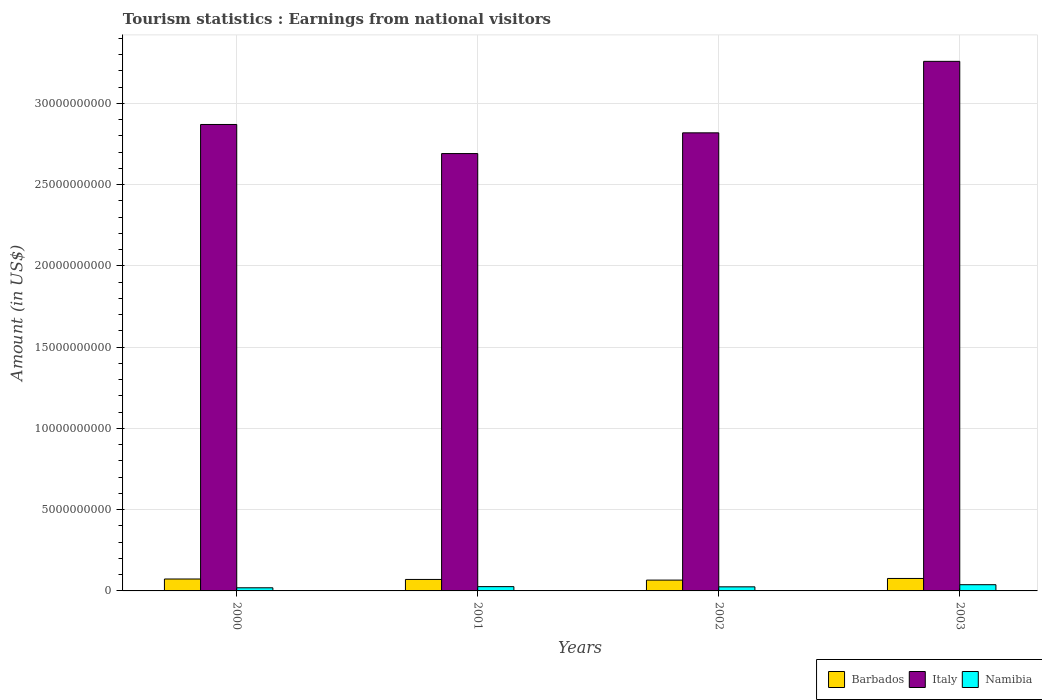How many different coloured bars are there?
Your response must be concise. 3. How many groups of bars are there?
Your answer should be very brief. 4. Are the number of bars per tick equal to the number of legend labels?
Keep it short and to the point. Yes. How many bars are there on the 1st tick from the left?
Provide a succinct answer. 3. How many bars are there on the 1st tick from the right?
Ensure brevity in your answer.  3. What is the earnings from national visitors in Italy in 2003?
Ensure brevity in your answer.  3.26e+1. Across all years, what is the maximum earnings from national visitors in Barbados?
Give a very brief answer. 7.67e+08. Across all years, what is the minimum earnings from national visitors in Namibia?
Provide a succinct answer. 1.93e+08. What is the total earnings from national visitors in Italy in the graph?
Ensure brevity in your answer.  1.16e+11. What is the difference between the earnings from national visitors in Italy in 2001 and that in 2003?
Ensure brevity in your answer.  -5.68e+09. What is the difference between the earnings from national visitors in Namibia in 2000 and the earnings from national visitors in Barbados in 2002?
Provide a short and direct response. -4.73e+08. What is the average earnings from national visitors in Namibia per year?
Your response must be concise. 2.73e+08. In the year 2003, what is the difference between the earnings from national visitors in Barbados and earnings from national visitors in Italy?
Provide a succinct answer. -3.18e+1. What is the ratio of the earnings from national visitors in Barbados in 2000 to that in 2003?
Provide a succinct answer. 0.96. What is the difference between the highest and the second highest earnings from national visitors in Italy?
Provide a succinct answer. 3.88e+09. What is the difference between the highest and the lowest earnings from national visitors in Barbados?
Your answer should be very brief. 1.01e+08. In how many years, is the earnings from national visitors in Italy greater than the average earnings from national visitors in Italy taken over all years?
Your response must be concise. 1. Is the sum of the earnings from national visitors in Barbados in 2001 and 2003 greater than the maximum earnings from national visitors in Italy across all years?
Keep it short and to the point. No. What does the 3rd bar from the right in 2001 represents?
Your response must be concise. Barbados. Are all the bars in the graph horizontal?
Make the answer very short. No. How many years are there in the graph?
Your answer should be compact. 4. Does the graph contain any zero values?
Make the answer very short. No. Does the graph contain grids?
Offer a very short reply. Yes. How many legend labels are there?
Provide a short and direct response. 3. How are the legend labels stacked?
Make the answer very short. Horizontal. What is the title of the graph?
Your answer should be very brief. Tourism statistics : Earnings from national visitors. What is the label or title of the Y-axis?
Keep it short and to the point. Amount (in US$). What is the Amount (in US$) of Barbados in 2000?
Make the answer very short. 7.33e+08. What is the Amount (in US$) in Italy in 2000?
Provide a short and direct response. 2.87e+1. What is the Amount (in US$) of Namibia in 2000?
Your response must be concise. 1.93e+08. What is the Amount (in US$) of Barbados in 2001?
Provide a short and direct response. 7.06e+08. What is the Amount (in US$) of Italy in 2001?
Offer a very short reply. 2.69e+1. What is the Amount (in US$) of Namibia in 2001?
Give a very brief answer. 2.64e+08. What is the Amount (in US$) of Barbados in 2002?
Make the answer very short. 6.66e+08. What is the Amount (in US$) of Italy in 2002?
Make the answer very short. 2.82e+1. What is the Amount (in US$) of Namibia in 2002?
Offer a very short reply. 2.51e+08. What is the Amount (in US$) of Barbados in 2003?
Your answer should be very brief. 7.67e+08. What is the Amount (in US$) in Italy in 2003?
Provide a succinct answer. 3.26e+1. What is the Amount (in US$) of Namibia in 2003?
Make the answer very short. 3.83e+08. Across all years, what is the maximum Amount (in US$) in Barbados?
Give a very brief answer. 7.67e+08. Across all years, what is the maximum Amount (in US$) of Italy?
Keep it short and to the point. 3.26e+1. Across all years, what is the maximum Amount (in US$) of Namibia?
Offer a very short reply. 3.83e+08. Across all years, what is the minimum Amount (in US$) in Barbados?
Your response must be concise. 6.66e+08. Across all years, what is the minimum Amount (in US$) of Italy?
Provide a succinct answer. 2.69e+1. Across all years, what is the minimum Amount (in US$) in Namibia?
Give a very brief answer. 1.93e+08. What is the total Amount (in US$) of Barbados in the graph?
Offer a very short reply. 2.87e+09. What is the total Amount (in US$) of Italy in the graph?
Offer a terse response. 1.16e+11. What is the total Amount (in US$) of Namibia in the graph?
Your answer should be compact. 1.09e+09. What is the difference between the Amount (in US$) in Barbados in 2000 and that in 2001?
Your answer should be very brief. 2.70e+07. What is the difference between the Amount (in US$) in Italy in 2000 and that in 2001?
Provide a short and direct response. 1.79e+09. What is the difference between the Amount (in US$) of Namibia in 2000 and that in 2001?
Make the answer very short. -7.10e+07. What is the difference between the Amount (in US$) of Barbados in 2000 and that in 2002?
Offer a terse response. 6.70e+07. What is the difference between the Amount (in US$) in Italy in 2000 and that in 2002?
Make the answer very short. 5.14e+08. What is the difference between the Amount (in US$) of Namibia in 2000 and that in 2002?
Give a very brief answer. -5.80e+07. What is the difference between the Amount (in US$) of Barbados in 2000 and that in 2003?
Your answer should be compact. -3.40e+07. What is the difference between the Amount (in US$) in Italy in 2000 and that in 2003?
Your answer should be compact. -3.88e+09. What is the difference between the Amount (in US$) in Namibia in 2000 and that in 2003?
Give a very brief answer. -1.90e+08. What is the difference between the Amount (in US$) of Barbados in 2001 and that in 2002?
Provide a succinct answer. 4.00e+07. What is the difference between the Amount (in US$) in Italy in 2001 and that in 2002?
Ensure brevity in your answer.  -1.28e+09. What is the difference between the Amount (in US$) of Namibia in 2001 and that in 2002?
Make the answer very short. 1.30e+07. What is the difference between the Amount (in US$) of Barbados in 2001 and that in 2003?
Provide a succinct answer. -6.10e+07. What is the difference between the Amount (in US$) in Italy in 2001 and that in 2003?
Your answer should be very brief. -5.68e+09. What is the difference between the Amount (in US$) of Namibia in 2001 and that in 2003?
Give a very brief answer. -1.19e+08. What is the difference between the Amount (in US$) of Barbados in 2002 and that in 2003?
Ensure brevity in your answer.  -1.01e+08. What is the difference between the Amount (in US$) in Italy in 2002 and that in 2003?
Ensure brevity in your answer.  -4.40e+09. What is the difference between the Amount (in US$) in Namibia in 2002 and that in 2003?
Make the answer very short. -1.32e+08. What is the difference between the Amount (in US$) of Barbados in 2000 and the Amount (in US$) of Italy in 2001?
Provide a short and direct response. -2.62e+1. What is the difference between the Amount (in US$) of Barbados in 2000 and the Amount (in US$) of Namibia in 2001?
Provide a short and direct response. 4.69e+08. What is the difference between the Amount (in US$) of Italy in 2000 and the Amount (in US$) of Namibia in 2001?
Give a very brief answer. 2.84e+1. What is the difference between the Amount (in US$) in Barbados in 2000 and the Amount (in US$) in Italy in 2002?
Provide a short and direct response. -2.75e+1. What is the difference between the Amount (in US$) of Barbados in 2000 and the Amount (in US$) of Namibia in 2002?
Your answer should be compact. 4.82e+08. What is the difference between the Amount (in US$) in Italy in 2000 and the Amount (in US$) in Namibia in 2002?
Keep it short and to the point. 2.85e+1. What is the difference between the Amount (in US$) in Barbados in 2000 and the Amount (in US$) in Italy in 2003?
Keep it short and to the point. -3.19e+1. What is the difference between the Amount (in US$) in Barbados in 2000 and the Amount (in US$) in Namibia in 2003?
Offer a terse response. 3.50e+08. What is the difference between the Amount (in US$) of Italy in 2000 and the Amount (in US$) of Namibia in 2003?
Offer a very short reply. 2.83e+1. What is the difference between the Amount (in US$) in Barbados in 2001 and the Amount (in US$) in Italy in 2002?
Provide a short and direct response. -2.75e+1. What is the difference between the Amount (in US$) in Barbados in 2001 and the Amount (in US$) in Namibia in 2002?
Your response must be concise. 4.55e+08. What is the difference between the Amount (in US$) of Italy in 2001 and the Amount (in US$) of Namibia in 2002?
Offer a very short reply. 2.67e+1. What is the difference between the Amount (in US$) in Barbados in 2001 and the Amount (in US$) in Italy in 2003?
Offer a very short reply. -3.19e+1. What is the difference between the Amount (in US$) of Barbados in 2001 and the Amount (in US$) of Namibia in 2003?
Give a very brief answer. 3.23e+08. What is the difference between the Amount (in US$) in Italy in 2001 and the Amount (in US$) in Namibia in 2003?
Provide a succinct answer. 2.65e+1. What is the difference between the Amount (in US$) of Barbados in 2002 and the Amount (in US$) of Italy in 2003?
Offer a very short reply. -3.19e+1. What is the difference between the Amount (in US$) in Barbados in 2002 and the Amount (in US$) in Namibia in 2003?
Give a very brief answer. 2.83e+08. What is the difference between the Amount (in US$) of Italy in 2002 and the Amount (in US$) of Namibia in 2003?
Offer a very short reply. 2.78e+1. What is the average Amount (in US$) in Barbados per year?
Keep it short and to the point. 7.18e+08. What is the average Amount (in US$) in Italy per year?
Your response must be concise. 2.91e+1. What is the average Amount (in US$) of Namibia per year?
Offer a terse response. 2.73e+08. In the year 2000, what is the difference between the Amount (in US$) in Barbados and Amount (in US$) in Italy?
Make the answer very short. -2.80e+1. In the year 2000, what is the difference between the Amount (in US$) in Barbados and Amount (in US$) in Namibia?
Provide a succinct answer. 5.40e+08. In the year 2000, what is the difference between the Amount (in US$) of Italy and Amount (in US$) of Namibia?
Keep it short and to the point. 2.85e+1. In the year 2001, what is the difference between the Amount (in US$) in Barbados and Amount (in US$) in Italy?
Your response must be concise. -2.62e+1. In the year 2001, what is the difference between the Amount (in US$) in Barbados and Amount (in US$) in Namibia?
Give a very brief answer. 4.42e+08. In the year 2001, what is the difference between the Amount (in US$) in Italy and Amount (in US$) in Namibia?
Make the answer very short. 2.67e+1. In the year 2002, what is the difference between the Amount (in US$) in Barbados and Amount (in US$) in Italy?
Ensure brevity in your answer.  -2.75e+1. In the year 2002, what is the difference between the Amount (in US$) in Barbados and Amount (in US$) in Namibia?
Your response must be concise. 4.15e+08. In the year 2002, what is the difference between the Amount (in US$) in Italy and Amount (in US$) in Namibia?
Make the answer very short. 2.79e+1. In the year 2003, what is the difference between the Amount (in US$) in Barbados and Amount (in US$) in Italy?
Give a very brief answer. -3.18e+1. In the year 2003, what is the difference between the Amount (in US$) in Barbados and Amount (in US$) in Namibia?
Give a very brief answer. 3.84e+08. In the year 2003, what is the difference between the Amount (in US$) in Italy and Amount (in US$) in Namibia?
Your answer should be compact. 3.22e+1. What is the ratio of the Amount (in US$) in Barbados in 2000 to that in 2001?
Ensure brevity in your answer.  1.04. What is the ratio of the Amount (in US$) in Italy in 2000 to that in 2001?
Your response must be concise. 1.07. What is the ratio of the Amount (in US$) in Namibia in 2000 to that in 2001?
Provide a short and direct response. 0.73. What is the ratio of the Amount (in US$) of Barbados in 2000 to that in 2002?
Provide a short and direct response. 1.1. What is the ratio of the Amount (in US$) of Italy in 2000 to that in 2002?
Ensure brevity in your answer.  1.02. What is the ratio of the Amount (in US$) in Namibia in 2000 to that in 2002?
Give a very brief answer. 0.77. What is the ratio of the Amount (in US$) in Barbados in 2000 to that in 2003?
Ensure brevity in your answer.  0.96. What is the ratio of the Amount (in US$) of Italy in 2000 to that in 2003?
Your answer should be very brief. 0.88. What is the ratio of the Amount (in US$) in Namibia in 2000 to that in 2003?
Provide a short and direct response. 0.5. What is the ratio of the Amount (in US$) of Barbados in 2001 to that in 2002?
Your answer should be compact. 1.06. What is the ratio of the Amount (in US$) of Italy in 2001 to that in 2002?
Ensure brevity in your answer.  0.95. What is the ratio of the Amount (in US$) of Namibia in 2001 to that in 2002?
Make the answer very short. 1.05. What is the ratio of the Amount (in US$) in Barbados in 2001 to that in 2003?
Your answer should be very brief. 0.92. What is the ratio of the Amount (in US$) in Italy in 2001 to that in 2003?
Give a very brief answer. 0.83. What is the ratio of the Amount (in US$) of Namibia in 2001 to that in 2003?
Keep it short and to the point. 0.69. What is the ratio of the Amount (in US$) in Barbados in 2002 to that in 2003?
Make the answer very short. 0.87. What is the ratio of the Amount (in US$) of Italy in 2002 to that in 2003?
Your answer should be compact. 0.86. What is the ratio of the Amount (in US$) of Namibia in 2002 to that in 2003?
Give a very brief answer. 0.66. What is the difference between the highest and the second highest Amount (in US$) in Barbados?
Offer a terse response. 3.40e+07. What is the difference between the highest and the second highest Amount (in US$) of Italy?
Your answer should be very brief. 3.88e+09. What is the difference between the highest and the second highest Amount (in US$) in Namibia?
Your answer should be very brief. 1.19e+08. What is the difference between the highest and the lowest Amount (in US$) of Barbados?
Give a very brief answer. 1.01e+08. What is the difference between the highest and the lowest Amount (in US$) in Italy?
Give a very brief answer. 5.68e+09. What is the difference between the highest and the lowest Amount (in US$) in Namibia?
Make the answer very short. 1.90e+08. 